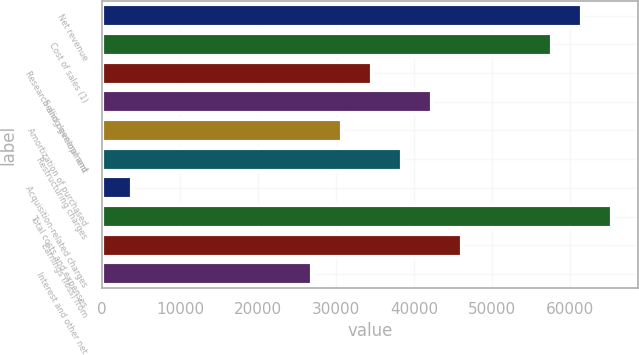<chart> <loc_0><loc_0><loc_500><loc_500><bar_chart><fcel>Net revenue<fcel>Cost of sales (1)<fcel>Research and development<fcel>Selling general and<fcel>Amortization of purchased<fcel>Restructuring charges<fcel>Acquisition-related charges<fcel>Total costs and expenses<fcel>Earnings (loss) from<fcel>Interest and other net<nl><fcel>61603.2<fcel>57753<fcel>34651.8<fcel>42352.2<fcel>30801.7<fcel>38502<fcel>3850.32<fcel>65453.4<fcel>46202.4<fcel>26951.5<nl></chart> 